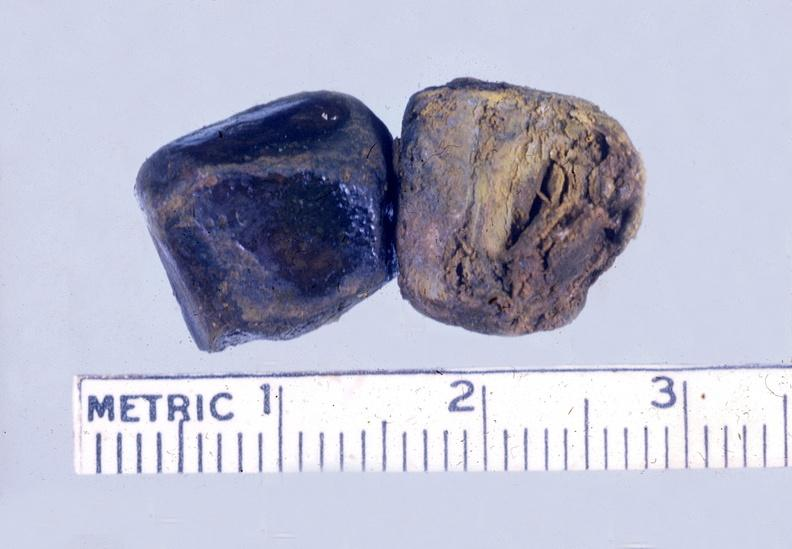s supernumerary digits present?
Answer the question using a single word or phrase. No 